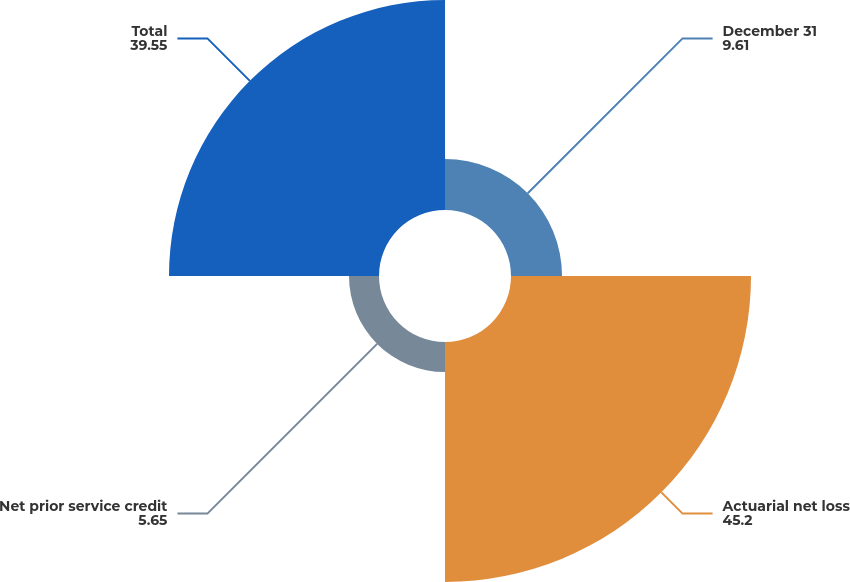Convert chart to OTSL. <chart><loc_0><loc_0><loc_500><loc_500><pie_chart><fcel>December 31<fcel>Actuarial net loss<fcel>Net prior service credit<fcel>Total<nl><fcel>9.61%<fcel>45.2%<fcel>5.65%<fcel>39.55%<nl></chart> 